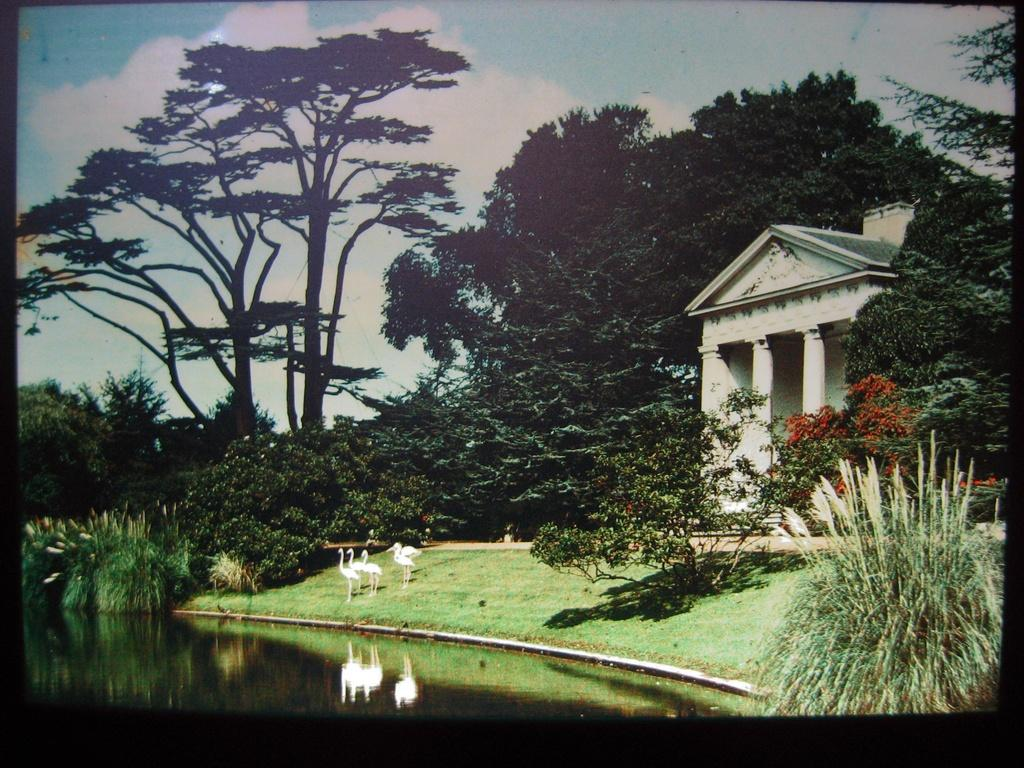What type of vegetation can be seen in the image? There are trees in the image. What type of structure is present in the image? There is a building in the image. What are the cranes in the image used for? The cranes in the image are likely used for construction or lifting heavy objects. What is the color and condition of the sky in the image? The sky is blue and cloudy in the image. What is the reflection of in the water? The reflection of the cranes is visible in the water. How many eggs are visible in the image? There are no eggs present in the image. What type of root is growing near the building in the image? There is no root visible in the image; only trees, a building, cranes, water, and the sky are present. 